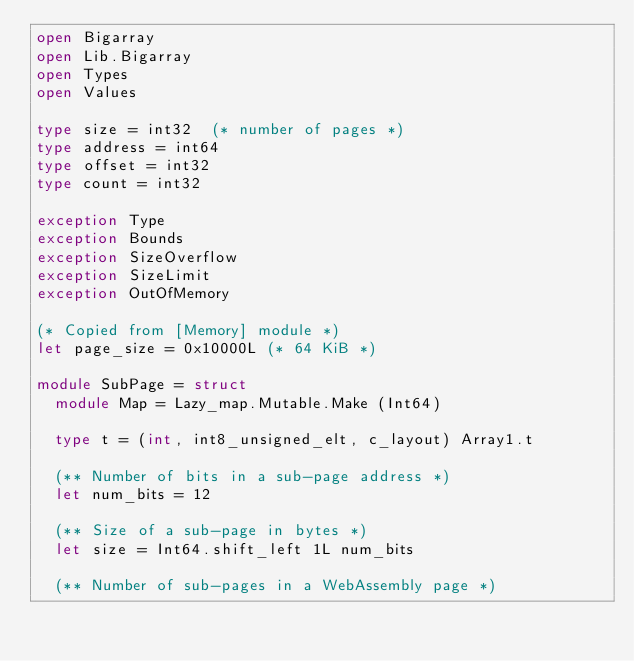Convert code to text. <code><loc_0><loc_0><loc_500><loc_500><_OCaml_>open Bigarray
open Lib.Bigarray
open Types
open Values

type size = int32  (* number of pages *)
type address = int64
type offset = int32
type count = int32

exception Type
exception Bounds
exception SizeOverflow
exception SizeLimit
exception OutOfMemory

(* Copied from [Memory] module *)
let page_size = 0x10000L (* 64 KiB *)

module SubPage = struct
  module Map = Lazy_map.Mutable.Make (Int64)

  type t = (int, int8_unsigned_elt, c_layout) Array1.t

  (** Number of bits in a sub-page address *)
  let num_bits = 12

  (** Size of a sub-page in bytes *)
  let size = Int64.shift_left 1L num_bits

  (** Number of sub-pages in a WebAssembly page *)</code> 